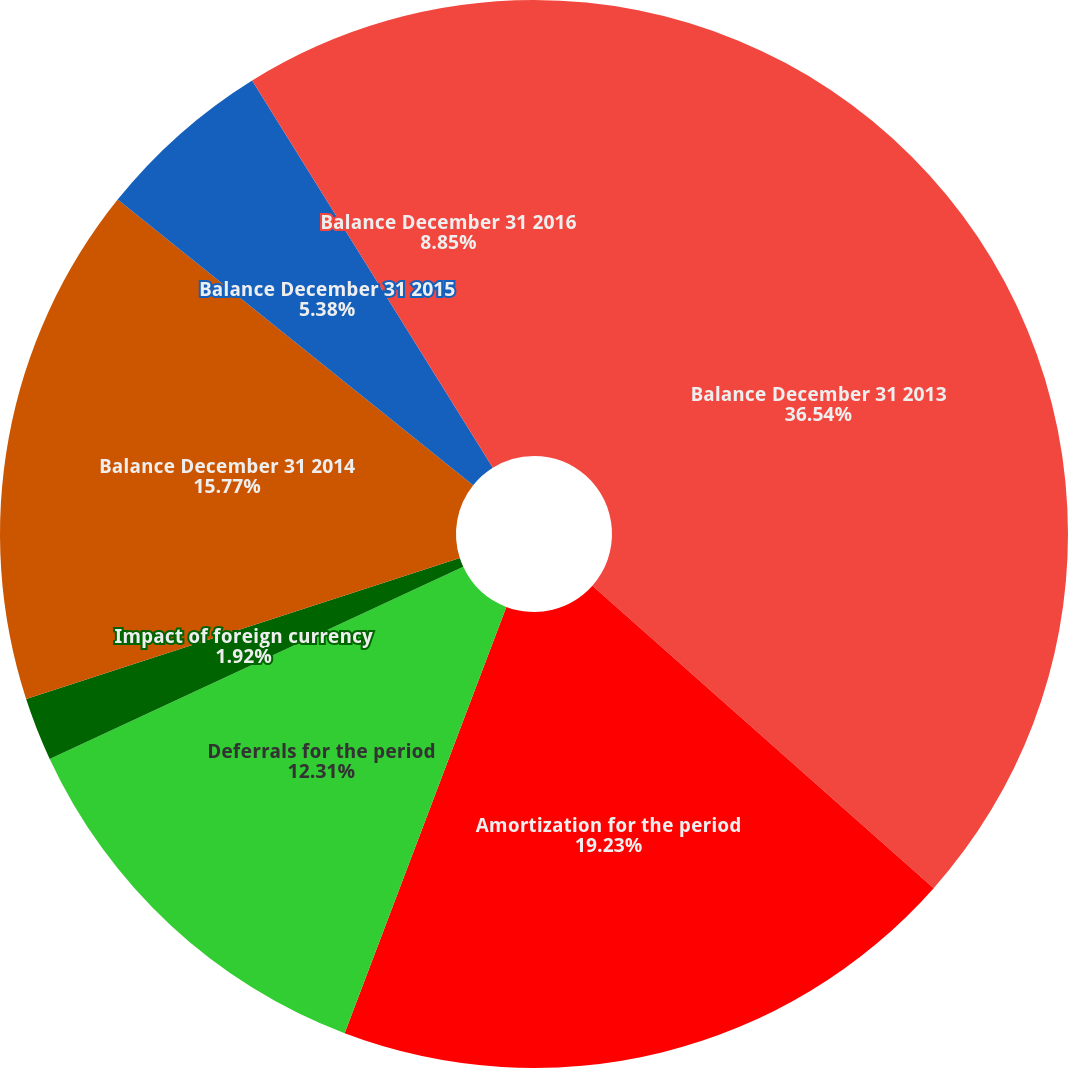Convert chart. <chart><loc_0><loc_0><loc_500><loc_500><pie_chart><fcel>Balance December 31 2013<fcel>Amortization for the period<fcel>Deferrals for the period<fcel>Impact of foreign currency<fcel>Balance December 31 2014<fcel>Balance December 31 2015<fcel>Balance December 31 2016<nl><fcel>36.54%<fcel>19.23%<fcel>12.31%<fcel>1.92%<fcel>15.77%<fcel>5.38%<fcel>8.85%<nl></chart> 